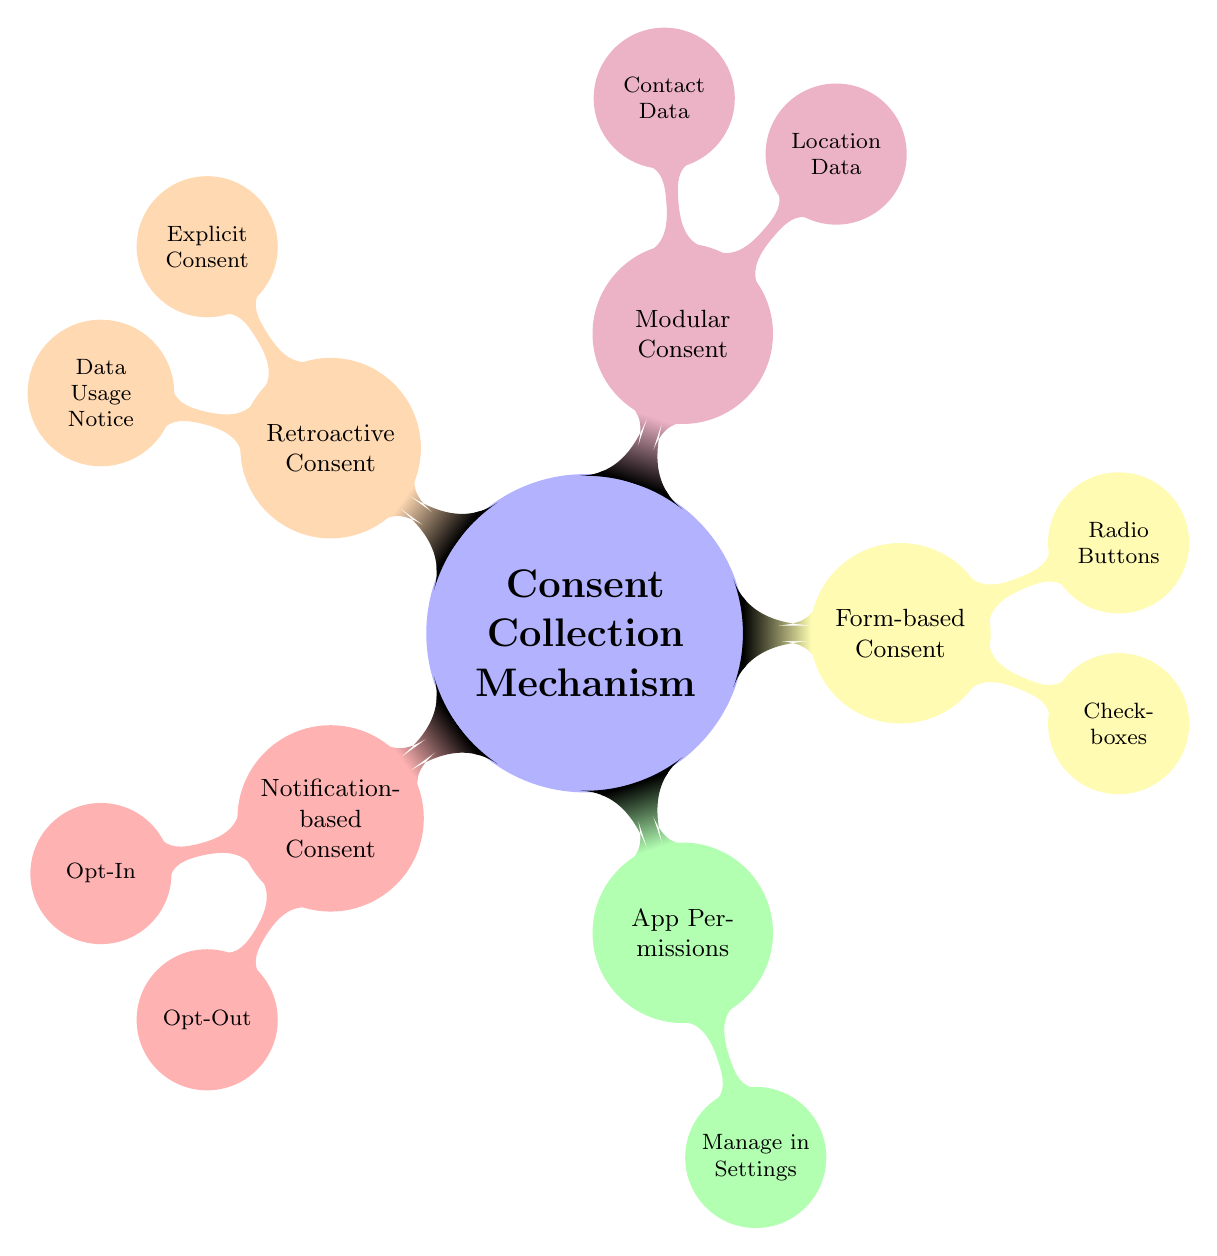What is the main topic of the diagram? The center node of the diagram is labeled "Consent Collection Mechanism," which indicates that it is the main topic being explored in this visualization.
Answer: Consent Collection Mechanism How many primary methods are illustrated for obtaining user consent? The diagram displays five primary methods branching out from the central topic: Notification-based Consent, App Permissions, Form-based Consent, Modular Consent, and Retroactive Consent.
Answer: Five What are the two options available under Notification-based Consent? Under the Notification-based Consent node, there are two child nodes labeled "Opt-In" and "Opt-Out," which provide the options related to user consent.
Answer: Opt-In and Opt-Out Which method allows users to manage permissions in Settings? The "App Permissions" method includes a child node labeled "Manage in Settings," referring to where users can control app permissions.
Answer: Manage in Settings What types of options does Form-based Consent include? The Form-based Consent method has two child nodes: "Checkboxes" and "Radio Buttons," indicating the types of user interface elements available for forms.
Answer: Checkboxes and Radio Buttons Which type of consent involves Location Data and Contact Data? The "Modular Consent" method contains two child nodes labeled "Location Data" and "Contact Data," indicating that these data types can be handled modularly for user consent.
Answer: Modular Consent What type of consent mechanism is described by Explicit Consent and Data Usage Notice? The diagram shows that the "Retroactive Consent" method encompasses "Explicit Consent" and "Data Usage Notice," highlighting a way to address consent after data has been collected.
Answer: Retroactive Consent Which color represents App Permissions in the diagram? The node for App Permissions is colored green, allowing us to visually identify this method in the diagram.
Answer: Green What is the relationship between Opt-Out and Notification-based Consent? Opt-Out is a child node directly connected to the Notification-based Consent node, denoting it as an option within this method.
Answer: Opt-Out is a child node 